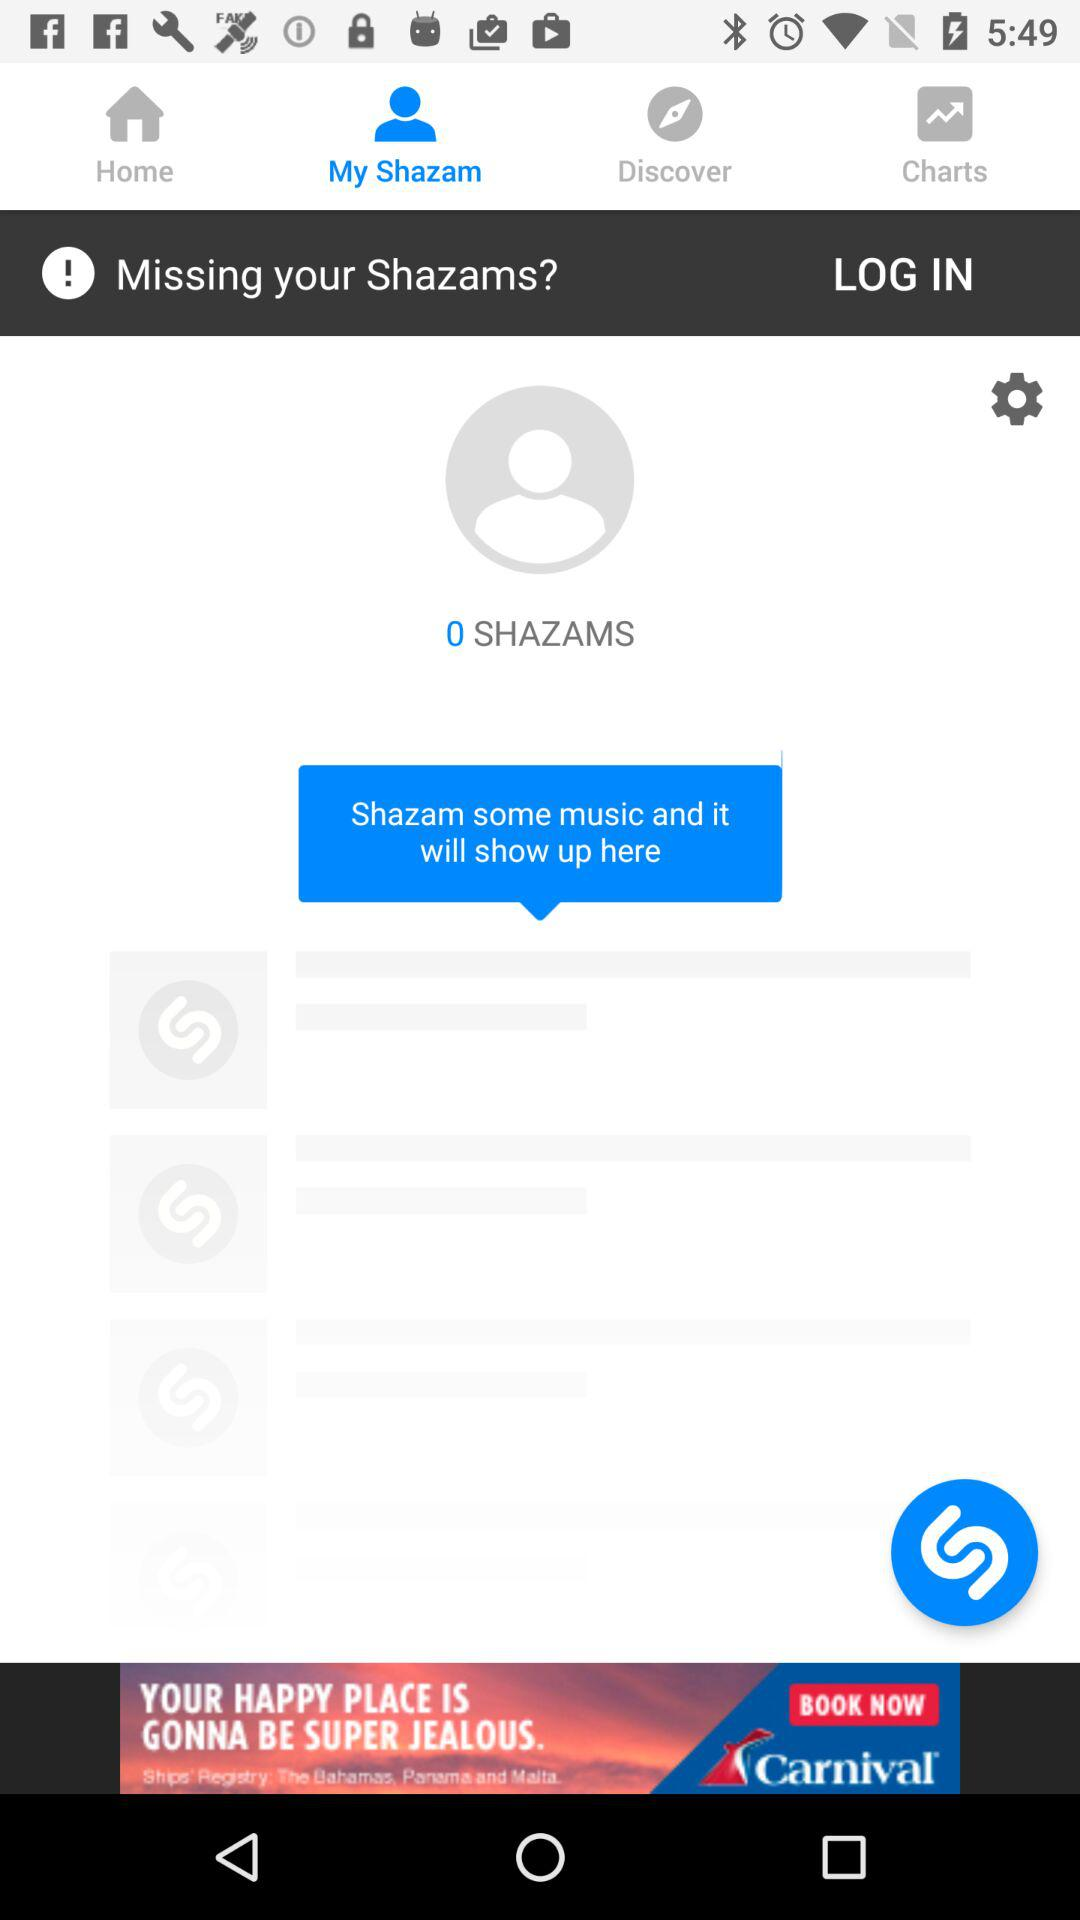What is the name of the user?
When the provided information is insufficient, respond with <no answer>. <no answer> 